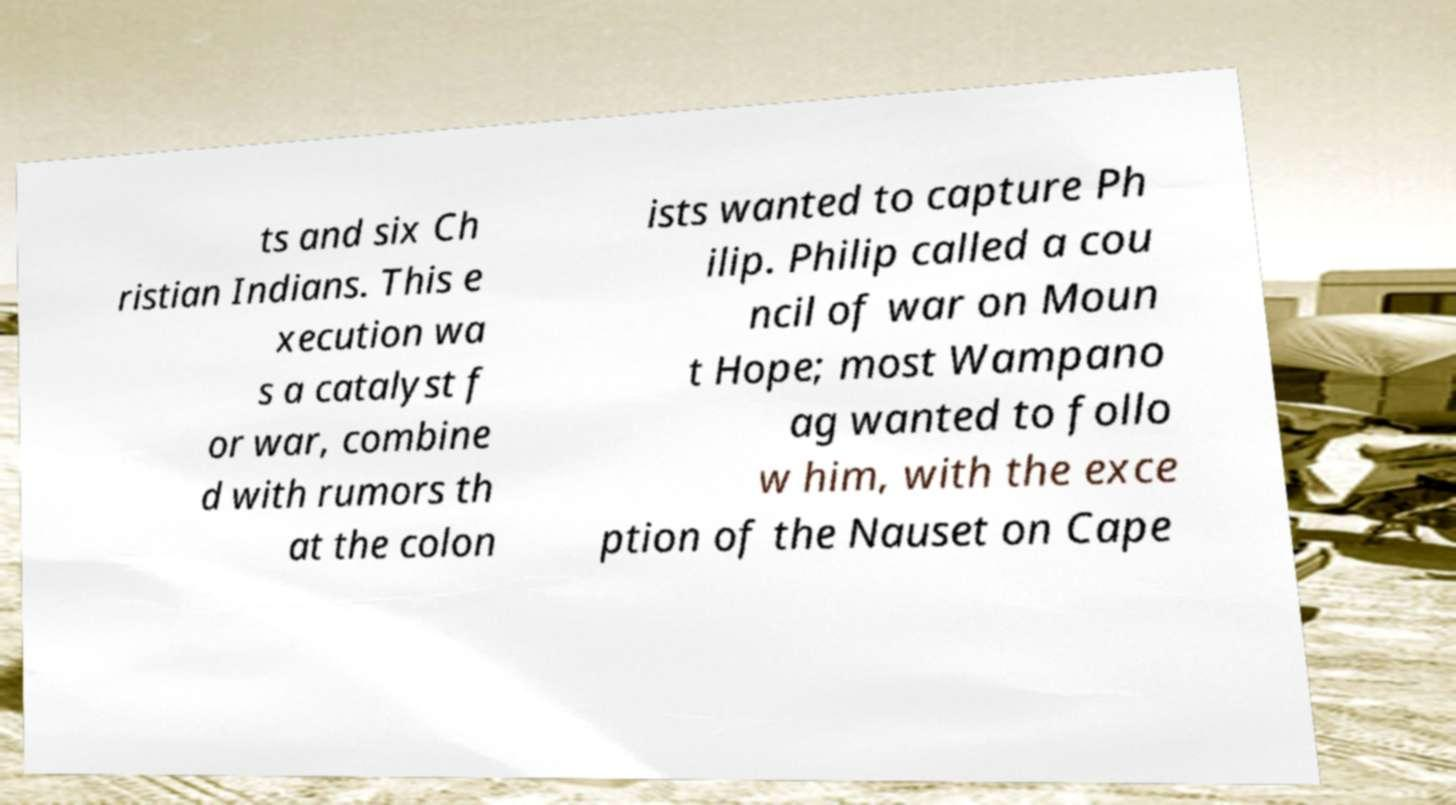For documentation purposes, I need the text within this image transcribed. Could you provide that? ts and six Ch ristian Indians. This e xecution wa s a catalyst f or war, combine d with rumors th at the colon ists wanted to capture Ph ilip. Philip called a cou ncil of war on Moun t Hope; most Wampano ag wanted to follo w him, with the exce ption of the Nauset on Cape 